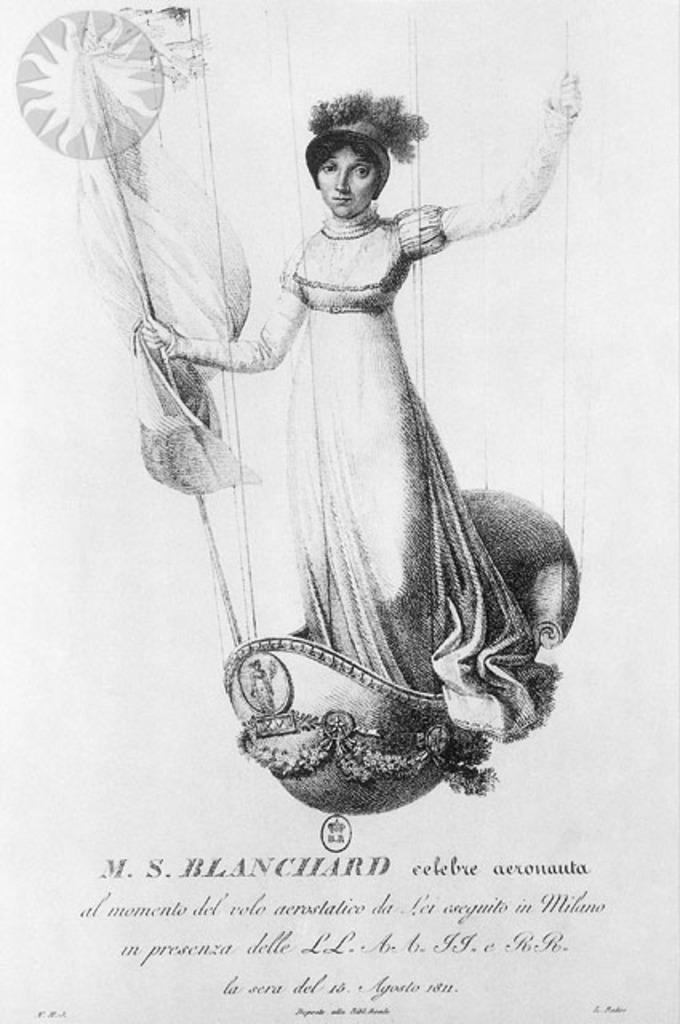In one or two sentences, can you explain what this image depicts? The image is in black and white, we can see there is a poster, there is a woman standing and holding a stick in the hand, at the bottom, there is some text written on it. 